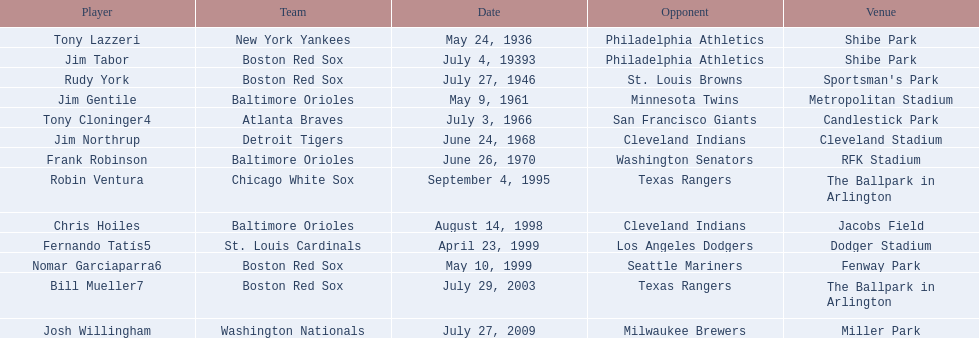Could you list the names of all the players? Tony Lazzeri, Jim Tabor, Rudy York, Jim Gentile, Tony Cloninger4, Jim Northrup, Frank Robinson, Robin Ventura, Chris Hoiles, Fernando Tatís5, Nomar Garciaparra6, Bill Mueller7, Josh Willingham. Which teams hold the home run records? New York Yankees, Boston Red Sox, Baltimore Orioles, Atlanta Braves, Detroit Tigers, Chicago White Sox, St. Louis Cardinals, Washington Nationals. Who was a player for the new york yankees? Tony Lazzeri. 